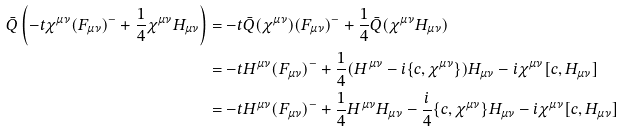<formula> <loc_0><loc_0><loc_500><loc_500>\bar { Q } \left ( - t \chi ^ { \mu \nu } ( F _ { \mu \nu } ) ^ { - } + \frac { 1 } { 4 } \chi ^ { \mu \nu } H _ { \mu \nu } \right ) & = - t \bar { Q } ( \chi ^ { \mu \nu } ) ( F _ { \mu \nu } ) ^ { - } + \frac { 1 } { 4 } \bar { Q } ( \chi ^ { \mu \nu } H _ { \mu \nu } ) \\ & = - t H ^ { \mu \nu } ( F _ { \mu \nu } ) ^ { - } + \frac { 1 } { 4 } ( H ^ { \mu \nu } - i \{ c , \chi ^ { \mu \nu } \} ) H _ { \mu \nu } - i \chi ^ { \mu \nu } [ c , H _ { \mu \nu } ] \\ & = - t H ^ { \mu \nu } ( F _ { \mu \nu } ) ^ { - } + \frac { 1 } { 4 } H ^ { \mu \nu } H _ { \mu \nu } - \frac { i } { 4 } \{ c , \chi ^ { \mu \nu } \} H _ { \mu \nu } - i \chi ^ { \mu \nu } [ c , H _ { \mu \nu } ]</formula> 